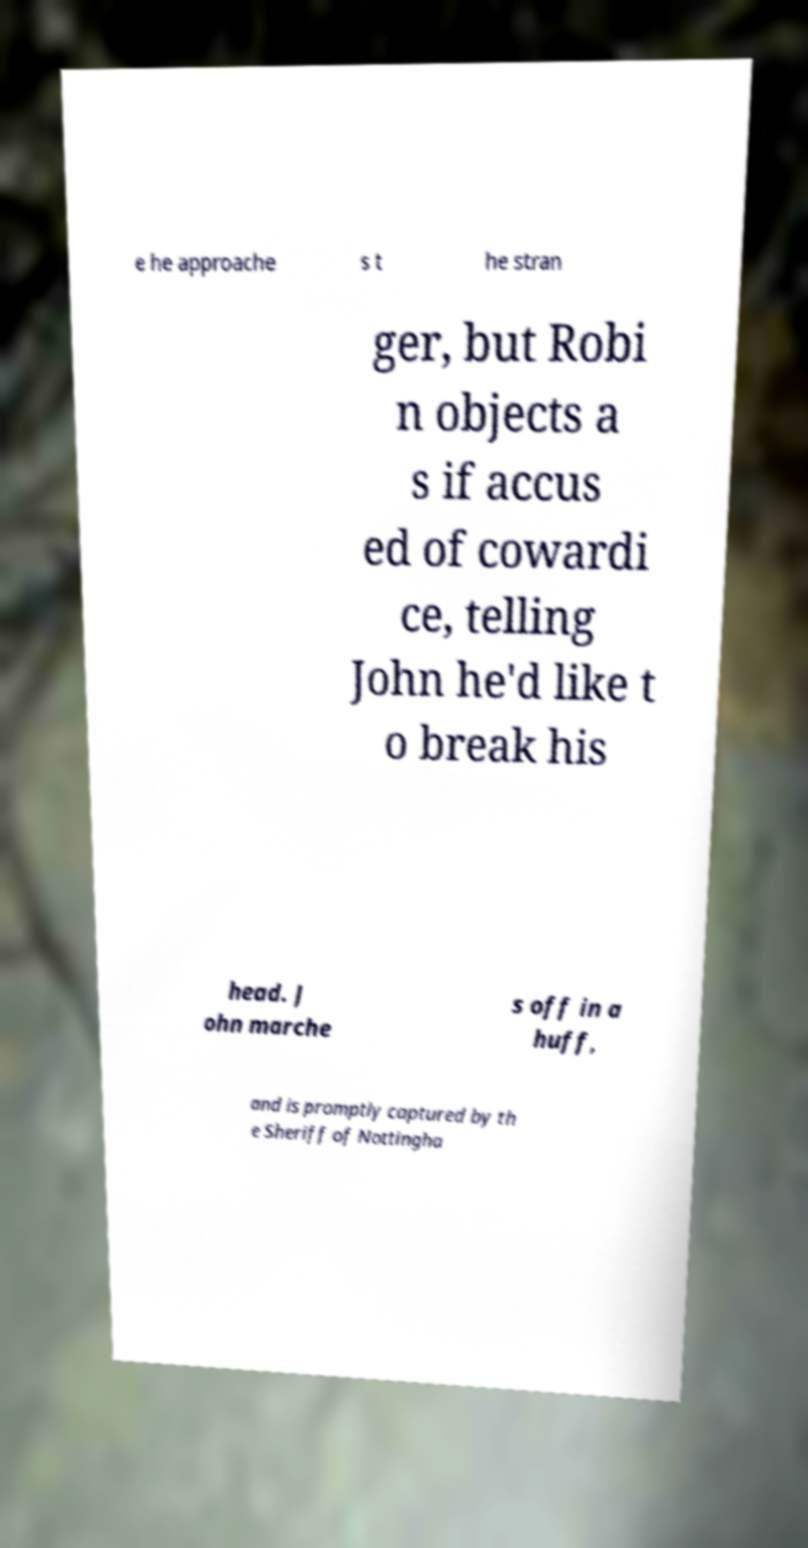What messages or text are displayed in this image? I need them in a readable, typed format. e he approache s t he stran ger, but Robi n objects a s if accus ed of cowardi ce, telling John he'd like t o break his head. J ohn marche s off in a huff, and is promptly captured by th e Sheriff of Nottingha 